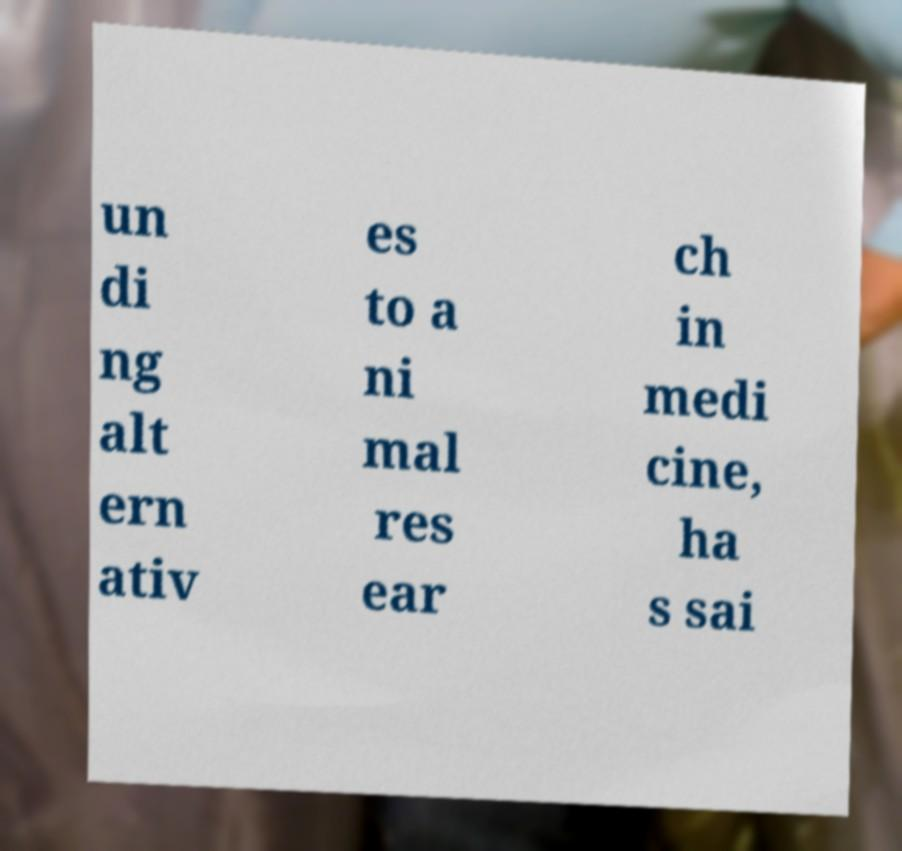There's text embedded in this image that I need extracted. Can you transcribe it verbatim? un di ng alt ern ativ es to a ni mal res ear ch in medi cine, ha s sai 